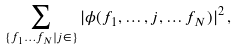Convert formula to latex. <formula><loc_0><loc_0><loc_500><loc_500>\sum _ { \{ f _ { 1 } \dots f _ { N } | j \in \} } | \phi ( f _ { 1 } , \dots , j , \dots f _ { N } ) | ^ { 2 } \, ,</formula> 